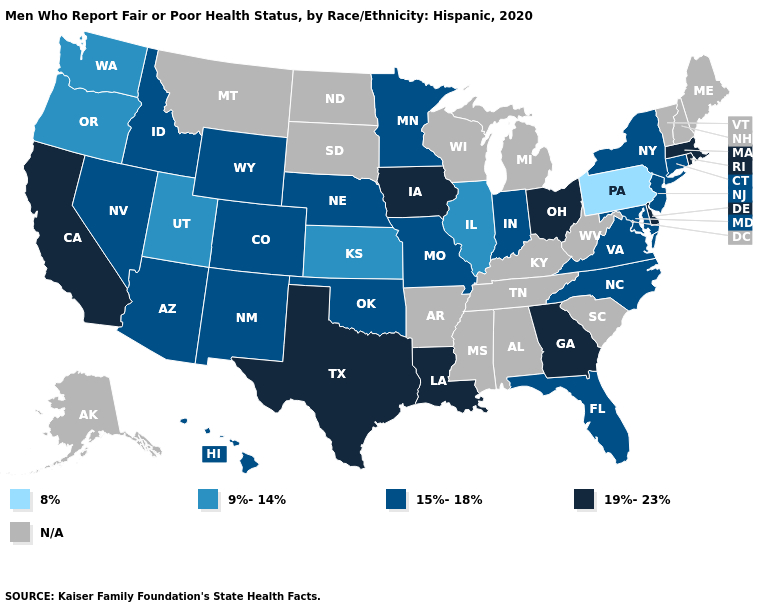Name the states that have a value in the range 8%?
Quick response, please. Pennsylvania. Among the states that border Iowa , which have the lowest value?
Concise answer only. Illinois. Name the states that have a value in the range N/A?
Give a very brief answer. Alabama, Alaska, Arkansas, Kentucky, Maine, Michigan, Mississippi, Montana, New Hampshire, North Dakota, South Carolina, South Dakota, Tennessee, Vermont, West Virginia, Wisconsin. What is the value of Iowa?
Give a very brief answer. 19%-23%. Does Texas have the highest value in the South?
Write a very short answer. Yes. Among the states that border Virginia , which have the highest value?
Be succinct. Maryland, North Carolina. Which states have the lowest value in the USA?
Give a very brief answer. Pennsylvania. Does the map have missing data?
Give a very brief answer. Yes. What is the lowest value in the USA?
Keep it brief. 8%. Does Pennsylvania have the lowest value in the USA?
Write a very short answer. Yes. Name the states that have a value in the range 8%?
Answer briefly. Pennsylvania. What is the value of Kentucky?
Short answer required. N/A. Does the map have missing data?
Give a very brief answer. Yes. 